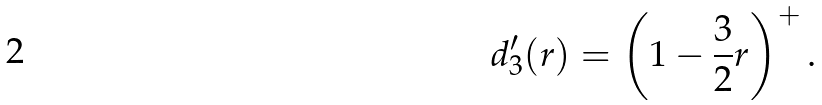Convert formula to latex. <formula><loc_0><loc_0><loc_500><loc_500>d _ { 3 } ^ { \prime } ( r ) = \left ( 1 - \frac { 3 } { 2 } r \right ) ^ { + } .</formula> 